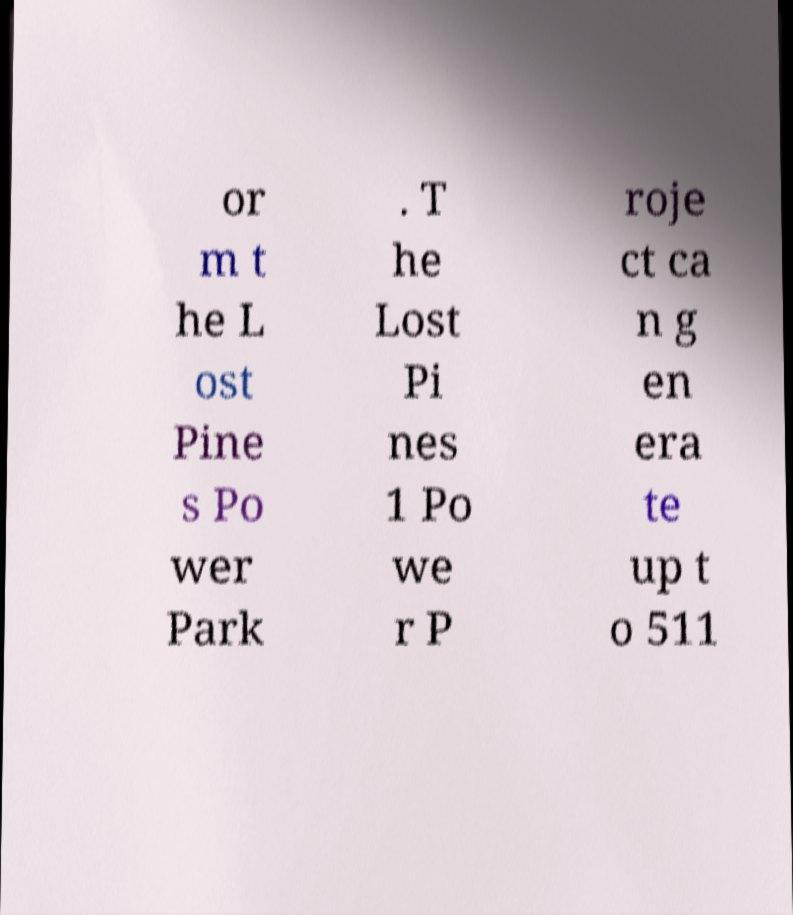Can you read and provide the text displayed in the image?This photo seems to have some interesting text. Can you extract and type it out for me? or m t he L ost Pine s Po wer Park . T he Lost Pi nes 1 Po we r P roje ct ca n g en era te up t o 511 